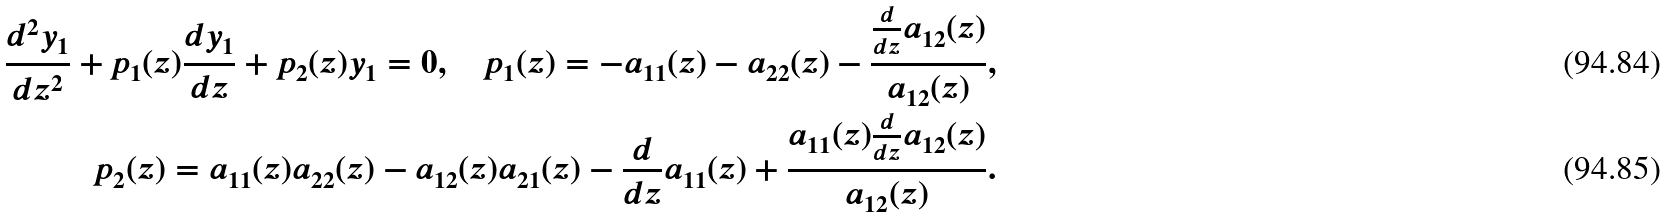<formula> <loc_0><loc_0><loc_500><loc_500>\frac { d ^ { 2 } y _ { 1 } } { d z ^ { 2 } } + p _ { 1 } ( z ) \frac { d y _ { 1 } } { d z } + p _ { 2 } ( z ) y _ { 1 } = 0 , \quad p _ { 1 } ( z ) = - a _ { 1 1 } ( z ) - a _ { 2 2 } ( z ) - \frac { \frac { d } { d z } a _ { 1 2 } ( z ) } { a _ { 1 2 } ( z ) } , \\ p _ { 2 } ( z ) = a _ { 1 1 } ( z ) a _ { 2 2 } ( z ) - a _ { 1 2 } ( z ) a _ { 2 1 } ( z ) - { { \frac { d } { d z } a _ { 1 1 } ( z ) } } + \frac { a _ { 1 1 } ( z ) \frac { d } { d z } a _ { 1 2 } ( z ) } { a _ { 1 2 } ( z ) } .</formula> 